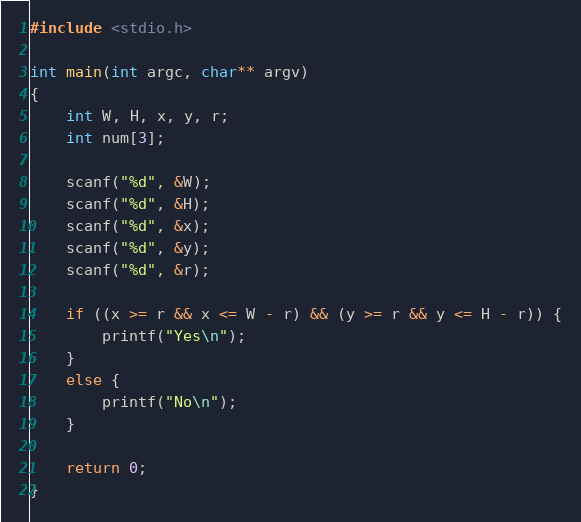Convert code to text. <code><loc_0><loc_0><loc_500><loc_500><_C_>#include <stdio.h>

int main(int argc, char** argv)
{
	int W, H, x, y, r;
	int num[3];

	scanf("%d", &W);
	scanf("%d", &H);
	scanf("%d", &x);
	scanf("%d", &y);
	scanf("%d", &r);

	if ((x >= r && x <= W - r) && (y >= r && y <= H - r)) {
		printf("Yes\n");
	}
	else {
		printf("No\n");
	}

	return 0;
}</code> 